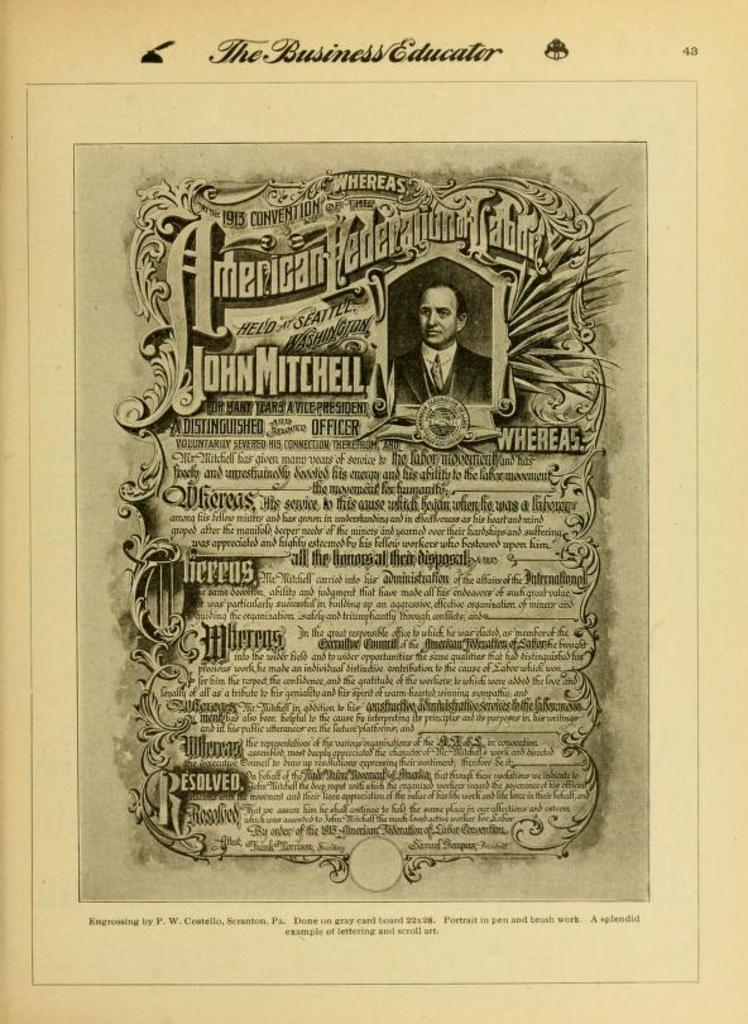What type of content is featured in the image? There is an article in the image. What kind of article is it? The article is from an editorial. What can be found within the article? There is text in the article. Is there any visual element in the image? Yes, there is a picture of a person in the image. How many bushes are visible in the image? There are no bushes present in the image; it features an article and a picture of a person. 